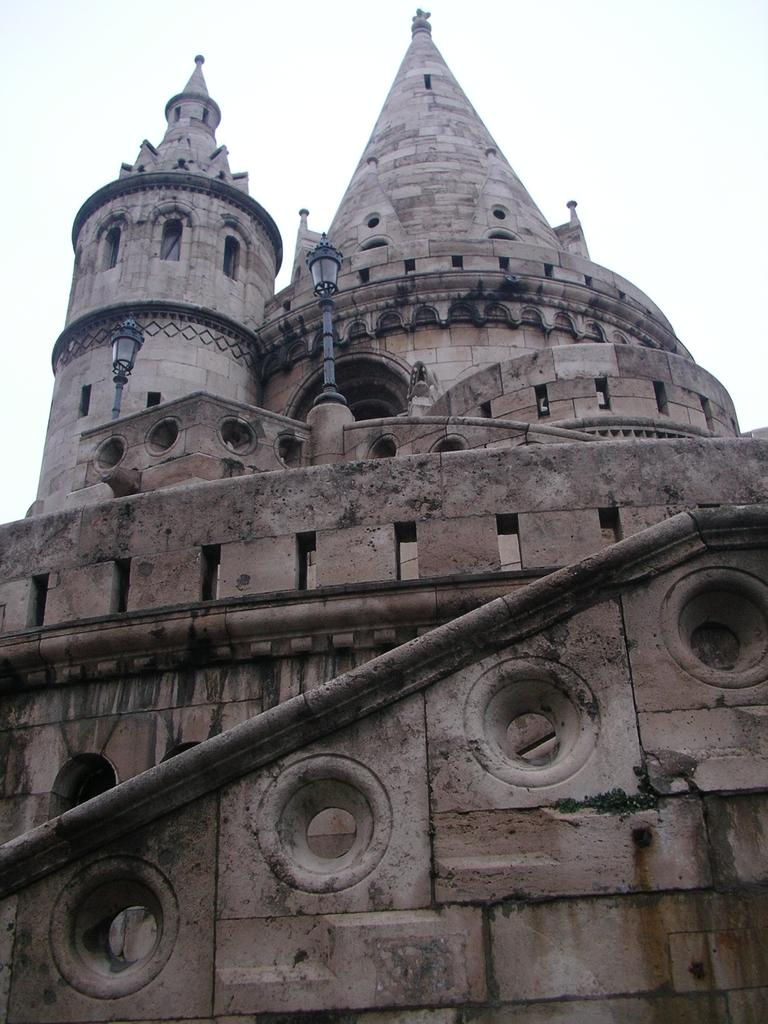What type of structure is present in the image? There is a building in the image. What is the color of the building? The building is brown in color. What other object can be seen in the image? There is a light pole in the image. What can be seen in the background of the image? The sky is visible in the background of the image. What is the color of the sky in the background? The color of the sky in the background is white. How many twigs are being used to burn in the image? There are no twigs or any indication of burning in the image. What type of joke is being told by the building in the image? There is no joke being told by the building or any other subject in the image. 